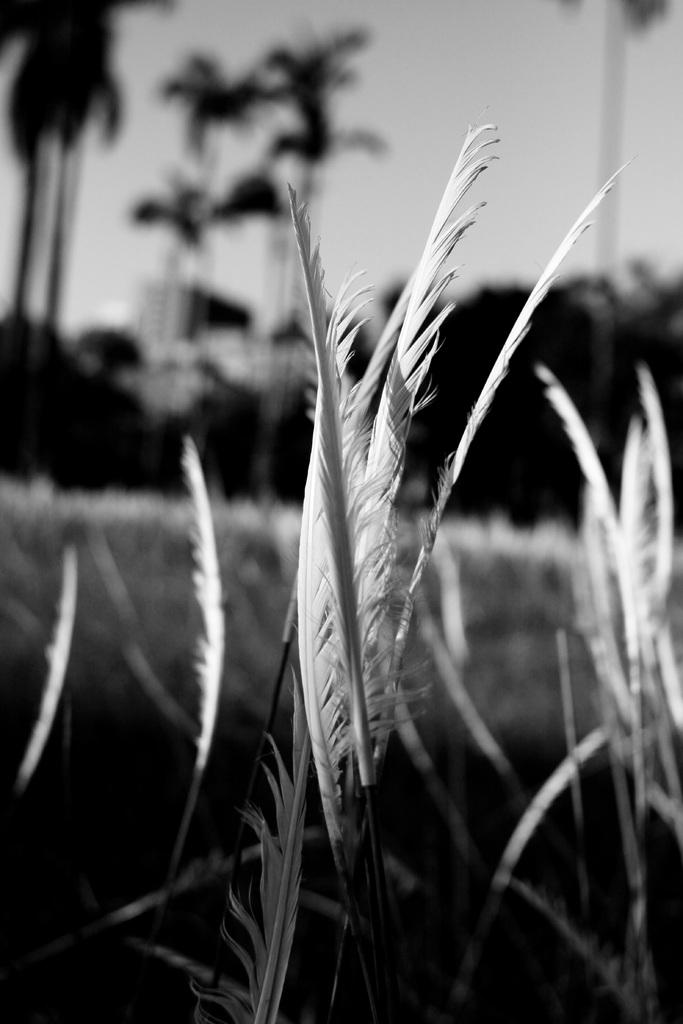What type of object resembles grass in the image? There is an object that looks like grass in the image. What can be seen in the background of the image? There are trees and the sky visible in the background of the image. Can you see any needles or fangs in the image? No, there are no needles or fangs present in the image. What type of test is being conducted in the image? There is no test being conducted in the image; it features an object that looks like grass, trees, and the sky. 